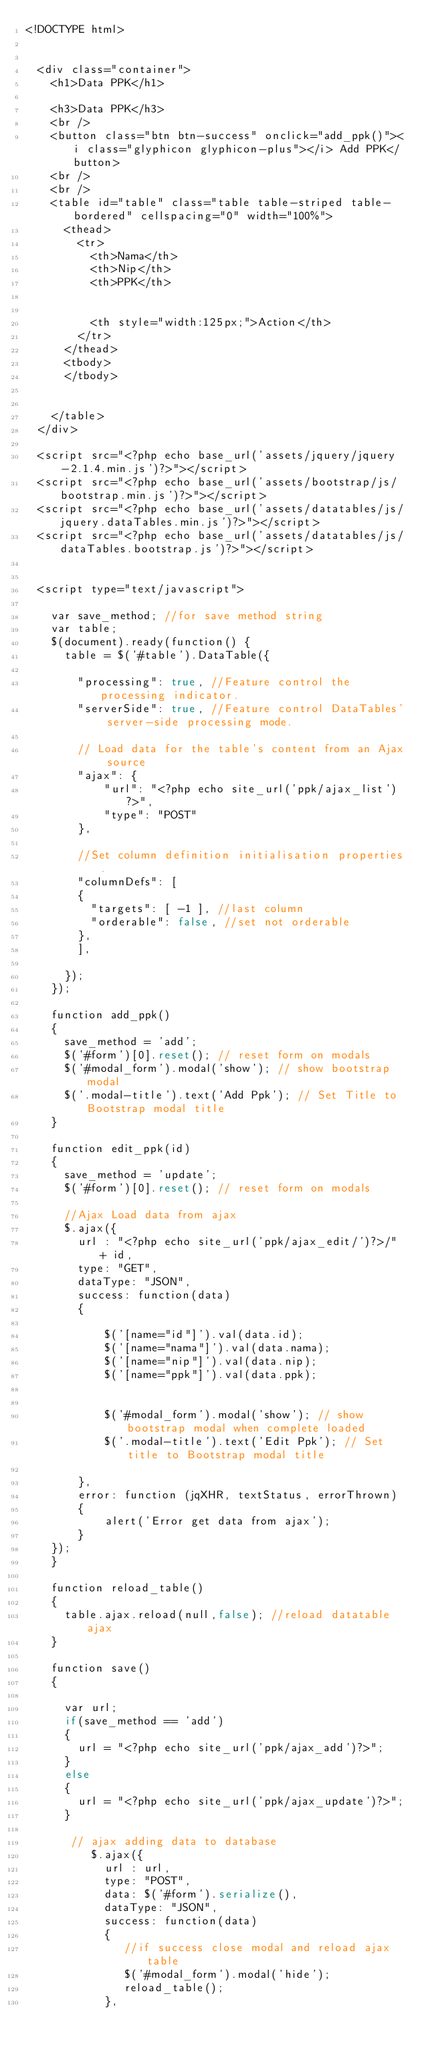Convert code to text. <code><loc_0><loc_0><loc_500><loc_500><_PHP_><!DOCTYPE html>


  <div class="container">
    <h1>Data PPK</h1>

    <h3>Data PPK</h3>
    <br />
    <button class="btn btn-success" onclick="add_ppk()"><i class="glyphicon glyphicon-plus"></i> Add PPK</button>
    <br />
    <br />
    <table id="table" class="table table-striped table-bordered" cellspacing="0" width="100%">
      <thead>
        <tr>
          <th>Nama</th>
          <th>Nip</th>
          <th>PPK</th>
         
         
          <th style="width:125px;">Action</th>
        </tr>
      </thead>
      <tbody>
      </tbody>

      
    </table>
  </div>

  <script src="<?php echo base_url('assets/jquery/jquery-2.1.4.min.js')?>"></script>
  <script src="<?php echo base_url('assets/bootstrap/js/bootstrap.min.js')?>"></script>
  <script src="<?php echo base_url('assets/datatables/js/jquery.dataTables.min.js')?>"></script>
  <script src="<?php echo base_url('assets/datatables/js/dataTables.bootstrap.js')?>"></script>


  <script type="text/javascript">

    var save_method; //for save method string
    var table;
    $(document).ready(function() {
      table = $('#table').DataTable({ 
        
        "processing": true, //Feature control the processing indicator.
        "serverSide": true, //Feature control DataTables' server-side processing mode.
        
        // Load data for the table's content from an Ajax source
        "ajax": {
            "url": "<?php echo site_url('ppk/ajax_list')?>",
            "type": "POST"
        },

        //Set column definition initialisation properties.
        "columnDefs": [
        { 
          "targets": [ -1 ], //last column
          "orderable": false, //set not orderable
        },
        ],

      });
    });

    function add_ppk()
    {
      save_method = 'add';
      $('#form')[0].reset(); // reset form on modals
      $('#modal_form').modal('show'); // show bootstrap modal
      $('.modal-title').text('Add Ppk'); // Set Title to Bootstrap modal title
    }

    function edit_ppk(id)
    {
      save_method = 'update';
      $('#form')[0].reset(); // reset form on modals

      //Ajax Load data from ajax
      $.ajax({
        url : "<?php echo site_url('ppk/ajax_edit/')?>/" + id,
        type: "GET",
        dataType: "JSON",
        success: function(data)
        {
           
            $('[name="id"]').val(data.id);
            $('[name="nama"]').val(data.nama);
            $('[name="nip"]').val(data.nip);
            $('[name="ppk"]').val(data.ppk);
           
            
            $('#modal_form').modal('show'); // show bootstrap modal when complete loaded
            $('.modal-title').text('Edit Ppk'); // Set title to Bootstrap modal title
            
        },
        error: function (jqXHR, textStatus, errorThrown)
        {
            alert('Error get data from ajax');
        }
    });
    }

    function reload_table()
    {
      table.ajax.reload(null,false); //reload datatable ajax 
    }

    function save()
    {
      
      var url;
      if(save_method == 'add') 
      {
        url = "<?php echo site_url('ppk/ajax_add')?>";
      }
      else
      {
        url = "<?php echo site_url('ppk/ajax_update')?>";
      }

       // ajax adding data to database
          $.ajax({
            url : url,
            type: "POST",
            data: $('#form').serialize(),
            dataType: "JSON",
            success: function(data)
            {
               //if success close modal and reload ajax table
               $('#modal_form').modal('hide');
               reload_table();
            },</code> 